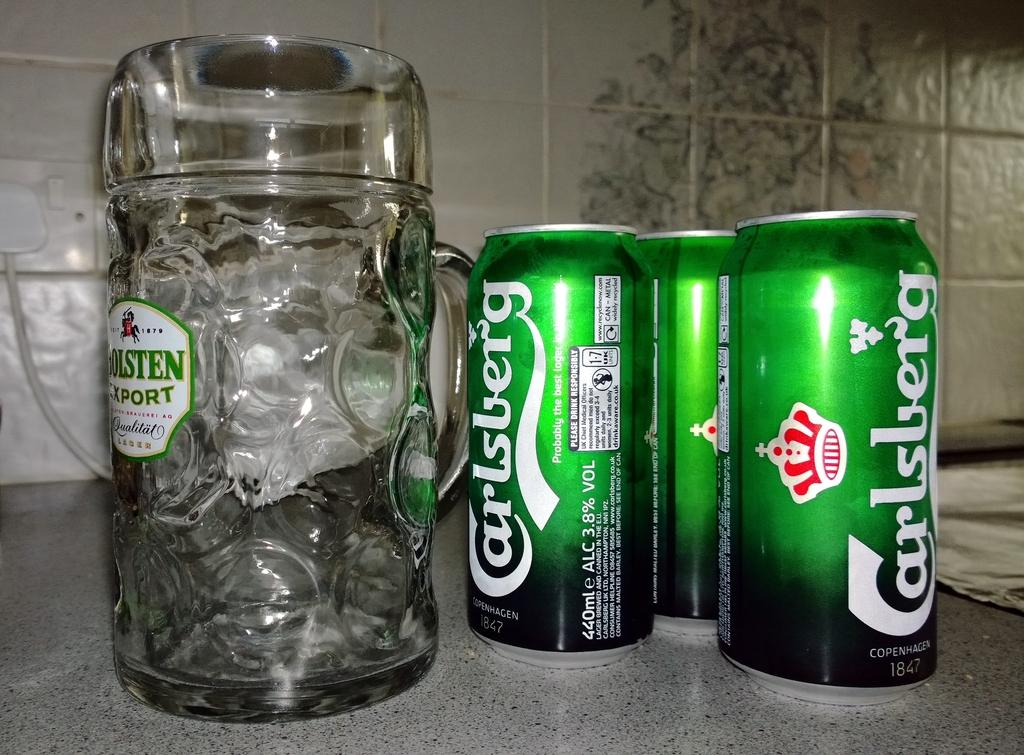What type of beverage containers are present in the image? There are coke tins in the image. What type of drinking vessel is visible in the image? There is a glass in the image. What material is the floor made of in the image? The floor in the image is made of marble. What type of surface can be seen in the background of the image? There are tiles visible in the background of the image. What type of mint is growing on the floor in the image? There is no mint growing on the floor in the image; the floor is made of marble. 